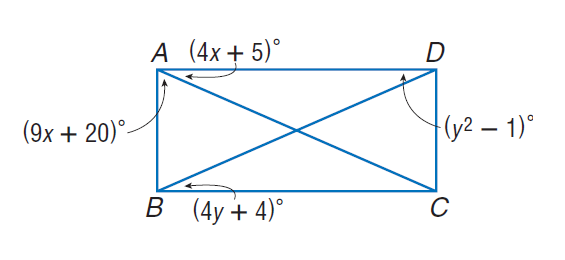Question: Quadrilateral A B C D is a rectangle. Find x.
Choices:
A. 5
B. 10
C. 20
D. 25
Answer with the letter. Answer: A Question: Quadrilateral A B C D is a rectangle. Find y.
Choices:
A. 5
B. 10
C. 15
D. 20
Answer with the letter. Answer: A 